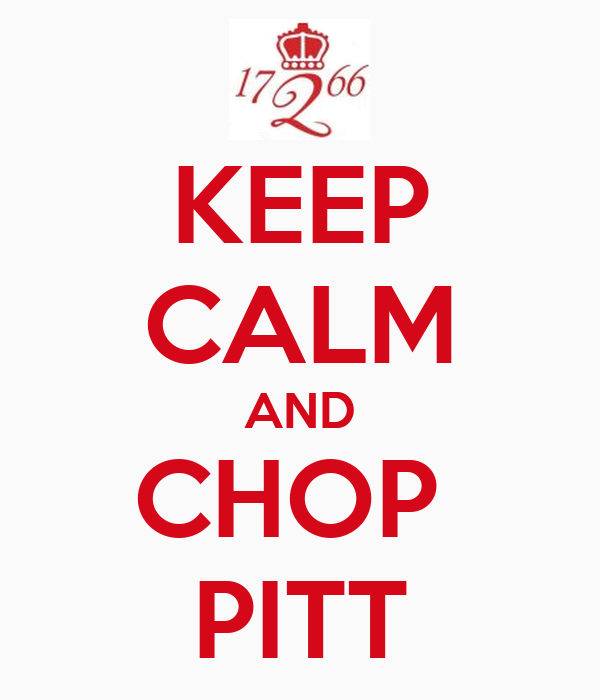Imagine this image is found in a fantasy world. What could be the scenario, and how might the inhabitants interpret it? In a fantasy world, this image might be a rallying cry used by a guild or kingdom preparing for battle against an opposing force named Pitt. The phrase 'Keep Calm and Chop Pitt' could be interpreted as a directive to maintain composure and focus while courageously confronting and defeating the enemy. The year "1766" might refer to a legendary battle that took place in the past, symbolizing a point of pride and a reminder of past victories. The emblem and message would serve to unite the inhabitants, bolster their morale, and remind them of their storied history and enduring strength. 